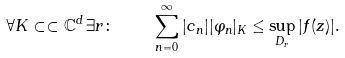Convert formula to latex. <formula><loc_0><loc_0><loc_500><loc_500>\forall K \subset \subset \mathbb { C } ^ { d } \, \exists r \colon \quad \sum _ { n = 0 } ^ { \infty } | c _ { n } | | \varphi _ { n } | _ { K } \leq \sup _ { D _ { r } } | f ( z ) | .</formula> 